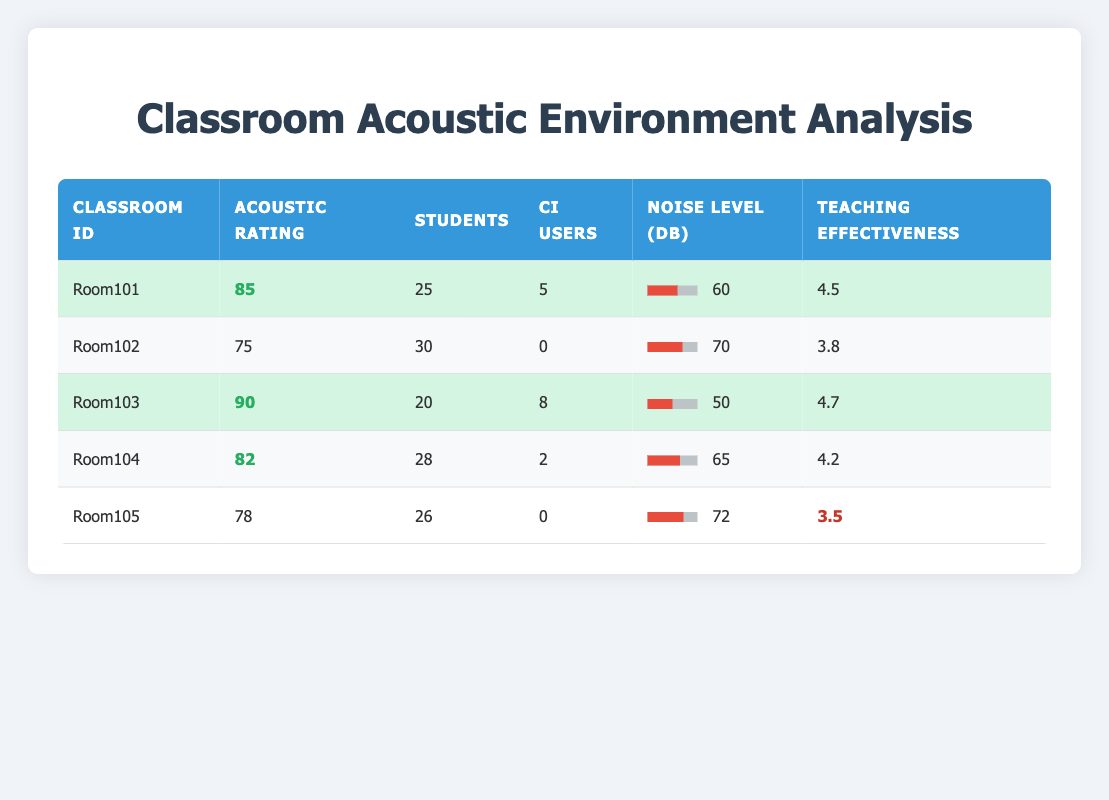What is the highest acoustic environment rating among the classrooms? Looking at the "Acoustic Rating" column, the highest value is 90, which corresponds to "Room103".
Answer: 90 How many students are there in total across all classrooms? Adding up the "Students" column: 25 (Room101) + 30 (Room102) + 20 (Room103) + 28 (Room104) + 26 (Room105) = 129.
Answer: 129 Is the average teaching effectiveness higher in classrooms with cochlear implant users compared to those without? The average for classrooms with cochlear implant users (Room101, Room103, Room104) is (4.5 + 4.7 + 4.2) / 3 = 4.47, while for those without (Room102, Room105) it's (3.8 + 3.5) / 2 = 3.65. Since 4.47 > 3.65, the statement is true.
Answer: Yes What is the noise level in decibels for Room104? Room104 has a reported noise level of 65 dB in the "Noise Level (dB)" column.
Answer: 65 dB What is the average number of cochlear implant users per classroom? There are 5 cochlear implant users in Room101, 0 in Room102, 8 in Room103, 2 in Room104, and 0 in Room105. Adding these gives 15 users. Since there are 5 classrooms, the average is 15 / 5 = 3.
Answer: 3 Do any classrooms with cochlear implant users have a noise level above 60 dB? Checking the "Noise Level (dB)" for classrooms with cochlear implant users shows Room101 has 60 dB, Room103 has 50 dB, Room104 has 65 dB. Room104 is above 60 dB, so the answer is yes.
Answer: Yes What is the teaching effectiveness score for the classroom with the highest number of cochlear implant users? The classroom with the highest number of cochlear implant users is Room103 with 8 users, and its teaching effectiveness score is 4.7.
Answer: 4.7 Which classroom has the lowest acoustic environment rating, and what is that rating? The lowest rating in the "Acoustic Rating" column is 75 from "Room102".
Answer: Room102, 75 